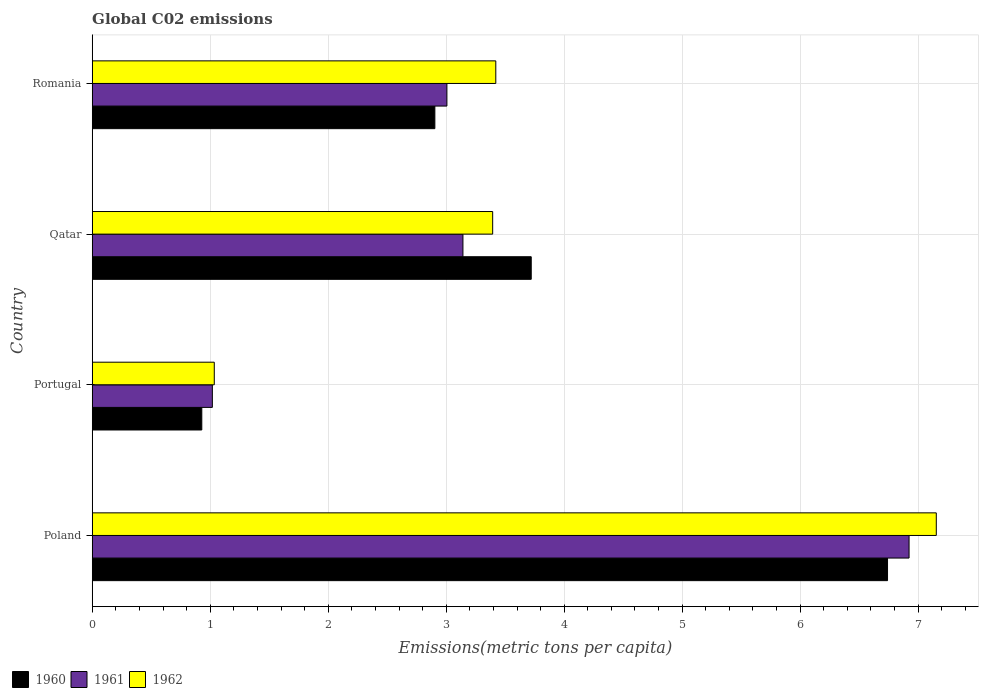How many different coloured bars are there?
Keep it short and to the point. 3. Are the number of bars on each tick of the Y-axis equal?
Offer a terse response. Yes. What is the label of the 1st group of bars from the top?
Provide a succinct answer. Romania. What is the amount of CO2 emitted in in 1961 in Poland?
Your answer should be very brief. 6.92. Across all countries, what is the maximum amount of CO2 emitted in in 1962?
Your answer should be compact. 7.15. Across all countries, what is the minimum amount of CO2 emitted in in 1960?
Your response must be concise. 0.93. In which country was the amount of CO2 emitted in in 1961 minimum?
Your answer should be compact. Portugal. What is the total amount of CO2 emitted in in 1960 in the graph?
Make the answer very short. 14.29. What is the difference between the amount of CO2 emitted in in 1960 in Poland and that in Qatar?
Your answer should be compact. 3.02. What is the difference between the amount of CO2 emitted in in 1961 in Qatar and the amount of CO2 emitted in in 1962 in Portugal?
Your response must be concise. 2.11. What is the average amount of CO2 emitted in in 1962 per country?
Make the answer very short. 3.75. What is the difference between the amount of CO2 emitted in in 1960 and amount of CO2 emitted in in 1961 in Romania?
Keep it short and to the point. -0.1. What is the ratio of the amount of CO2 emitted in in 1962 in Portugal to that in Romania?
Make the answer very short. 0.3. Is the amount of CO2 emitted in in 1962 in Poland less than that in Romania?
Your response must be concise. No. Is the difference between the amount of CO2 emitted in in 1960 in Portugal and Qatar greater than the difference between the amount of CO2 emitted in in 1961 in Portugal and Qatar?
Keep it short and to the point. No. What is the difference between the highest and the second highest amount of CO2 emitted in in 1962?
Give a very brief answer. 3.73. What is the difference between the highest and the lowest amount of CO2 emitted in in 1962?
Your response must be concise. 6.12. In how many countries, is the amount of CO2 emitted in in 1960 greater than the average amount of CO2 emitted in in 1960 taken over all countries?
Offer a very short reply. 2. What does the 1st bar from the top in Romania represents?
Your response must be concise. 1962. What does the 3rd bar from the bottom in Poland represents?
Your answer should be compact. 1962. Is it the case that in every country, the sum of the amount of CO2 emitted in in 1962 and amount of CO2 emitted in in 1960 is greater than the amount of CO2 emitted in in 1961?
Your answer should be compact. Yes. How many bars are there?
Your response must be concise. 12. What is the difference between two consecutive major ticks on the X-axis?
Your answer should be very brief. 1. Are the values on the major ticks of X-axis written in scientific E-notation?
Your answer should be compact. No. Does the graph contain any zero values?
Your response must be concise. No. Does the graph contain grids?
Give a very brief answer. Yes. Where does the legend appear in the graph?
Give a very brief answer. Bottom left. How many legend labels are there?
Make the answer very short. 3. How are the legend labels stacked?
Make the answer very short. Horizontal. What is the title of the graph?
Your answer should be very brief. Global C02 emissions. What is the label or title of the X-axis?
Keep it short and to the point. Emissions(metric tons per capita). What is the Emissions(metric tons per capita) of 1960 in Poland?
Your response must be concise. 6.74. What is the Emissions(metric tons per capita) of 1961 in Poland?
Offer a very short reply. 6.92. What is the Emissions(metric tons per capita) in 1962 in Poland?
Your response must be concise. 7.15. What is the Emissions(metric tons per capita) of 1960 in Portugal?
Make the answer very short. 0.93. What is the Emissions(metric tons per capita) in 1961 in Portugal?
Your answer should be very brief. 1.02. What is the Emissions(metric tons per capita) of 1962 in Portugal?
Offer a very short reply. 1.03. What is the Emissions(metric tons per capita) of 1960 in Qatar?
Give a very brief answer. 3.72. What is the Emissions(metric tons per capita) of 1961 in Qatar?
Provide a succinct answer. 3.14. What is the Emissions(metric tons per capita) of 1962 in Qatar?
Ensure brevity in your answer.  3.39. What is the Emissions(metric tons per capita) in 1960 in Romania?
Provide a short and direct response. 2.9. What is the Emissions(metric tons per capita) of 1961 in Romania?
Your response must be concise. 3.01. What is the Emissions(metric tons per capita) of 1962 in Romania?
Offer a terse response. 3.42. Across all countries, what is the maximum Emissions(metric tons per capita) of 1960?
Provide a succinct answer. 6.74. Across all countries, what is the maximum Emissions(metric tons per capita) in 1961?
Keep it short and to the point. 6.92. Across all countries, what is the maximum Emissions(metric tons per capita) of 1962?
Ensure brevity in your answer.  7.15. Across all countries, what is the minimum Emissions(metric tons per capita) of 1960?
Keep it short and to the point. 0.93. Across all countries, what is the minimum Emissions(metric tons per capita) of 1961?
Provide a short and direct response. 1.02. Across all countries, what is the minimum Emissions(metric tons per capita) in 1962?
Ensure brevity in your answer.  1.03. What is the total Emissions(metric tons per capita) in 1960 in the graph?
Ensure brevity in your answer.  14.29. What is the total Emissions(metric tons per capita) of 1961 in the graph?
Give a very brief answer. 14.09. What is the total Emissions(metric tons per capita) in 1962 in the graph?
Offer a very short reply. 15. What is the difference between the Emissions(metric tons per capita) of 1960 in Poland and that in Portugal?
Provide a short and direct response. 5.81. What is the difference between the Emissions(metric tons per capita) of 1961 in Poland and that in Portugal?
Offer a terse response. 5.9. What is the difference between the Emissions(metric tons per capita) of 1962 in Poland and that in Portugal?
Your answer should be compact. 6.12. What is the difference between the Emissions(metric tons per capita) in 1960 in Poland and that in Qatar?
Ensure brevity in your answer.  3.02. What is the difference between the Emissions(metric tons per capita) of 1961 in Poland and that in Qatar?
Keep it short and to the point. 3.78. What is the difference between the Emissions(metric tons per capita) in 1962 in Poland and that in Qatar?
Offer a very short reply. 3.76. What is the difference between the Emissions(metric tons per capita) of 1960 in Poland and that in Romania?
Your answer should be very brief. 3.84. What is the difference between the Emissions(metric tons per capita) of 1961 in Poland and that in Romania?
Your answer should be compact. 3.92. What is the difference between the Emissions(metric tons per capita) of 1962 in Poland and that in Romania?
Offer a terse response. 3.73. What is the difference between the Emissions(metric tons per capita) of 1960 in Portugal and that in Qatar?
Ensure brevity in your answer.  -2.79. What is the difference between the Emissions(metric tons per capita) in 1961 in Portugal and that in Qatar?
Make the answer very short. -2.12. What is the difference between the Emissions(metric tons per capita) in 1962 in Portugal and that in Qatar?
Keep it short and to the point. -2.36. What is the difference between the Emissions(metric tons per capita) in 1960 in Portugal and that in Romania?
Offer a terse response. -1.98. What is the difference between the Emissions(metric tons per capita) in 1961 in Portugal and that in Romania?
Your answer should be compact. -1.99. What is the difference between the Emissions(metric tons per capita) in 1962 in Portugal and that in Romania?
Provide a short and direct response. -2.39. What is the difference between the Emissions(metric tons per capita) in 1960 in Qatar and that in Romania?
Your answer should be very brief. 0.82. What is the difference between the Emissions(metric tons per capita) of 1961 in Qatar and that in Romania?
Keep it short and to the point. 0.14. What is the difference between the Emissions(metric tons per capita) in 1962 in Qatar and that in Romania?
Your answer should be compact. -0.03. What is the difference between the Emissions(metric tons per capita) of 1960 in Poland and the Emissions(metric tons per capita) of 1961 in Portugal?
Ensure brevity in your answer.  5.72. What is the difference between the Emissions(metric tons per capita) of 1960 in Poland and the Emissions(metric tons per capita) of 1962 in Portugal?
Ensure brevity in your answer.  5.71. What is the difference between the Emissions(metric tons per capita) of 1961 in Poland and the Emissions(metric tons per capita) of 1962 in Portugal?
Make the answer very short. 5.89. What is the difference between the Emissions(metric tons per capita) in 1960 in Poland and the Emissions(metric tons per capita) in 1961 in Qatar?
Your response must be concise. 3.6. What is the difference between the Emissions(metric tons per capita) in 1960 in Poland and the Emissions(metric tons per capita) in 1962 in Qatar?
Offer a terse response. 3.35. What is the difference between the Emissions(metric tons per capita) of 1961 in Poland and the Emissions(metric tons per capita) of 1962 in Qatar?
Your response must be concise. 3.53. What is the difference between the Emissions(metric tons per capita) of 1960 in Poland and the Emissions(metric tons per capita) of 1961 in Romania?
Provide a short and direct response. 3.73. What is the difference between the Emissions(metric tons per capita) of 1960 in Poland and the Emissions(metric tons per capita) of 1962 in Romania?
Give a very brief answer. 3.32. What is the difference between the Emissions(metric tons per capita) of 1961 in Poland and the Emissions(metric tons per capita) of 1962 in Romania?
Give a very brief answer. 3.5. What is the difference between the Emissions(metric tons per capita) in 1960 in Portugal and the Emissions(metric tons per capita) in 1961 in Qatar?
Keep it short and to the point. -2.21. What is the difference between the Emissions(metric tons per capita) in 1960 in Portugal and the Emissions(metric tons per capita) in 1962 in Qatar?
Make the answer very short. -2.47. What is the difference between the Emissions(metric tons per capita) in 1961 in Portugal and the Emissions(metric tons per capita) in 1962 in Qatar?
Keep it short and to the point. -2.38. What is the difference between the Emissions(metric tons per capita) in 1960 in Portugal and the Emissions(metric tons per capita) in 1961 in Romania?
Your answer should be compact. -2.08. What is the difference between the Emissions(metric tons per capita) in 1960 in Portugal and the Emissions(metric tons per capita) in 1962 in Romania?
Provide a succinct answer. -2.49. What is the difference between the Emissions(metric tons per capita) of 1961 in Portugal and the Emissions(metric tons per capita) of 1962 in Romania?
Ensure brevity in your answer.  -2.4. What is the difference between the Emissions(metric tons per capita) of 1960 in Qatar and the Emissions(metric tons per capita) of 1961 in Romania?
Offer a very short reply. 0.71. What is the difference between the Emissions(metric tons per capita) in 1960 in Qatar and the Emissions(metric tons per capita) in 1962 in Romania?
Provide a succinct answer. 0.3. What is the difference between the Emissions(metric tons per capita) in 1961 in Qatar and the Emissions(metric tons per capita) in 1962 in Romania?
Offer a very short reply. -0.28. What is the average Emissions(metric tons per capita) of 1960 per country?
Offer a terse response. 3.57. What is the average Emissions(metric tons per capita) of 1961 per country?
Your answer should be very brief. 3.52. What is the average Emissions(metric tons per capita) in 1962 per country?
Ensure brevity in your answer.  3.75. What is the difference between the Emissions(metric tons per capita) of 1960 and Emissions(metric tons per capita) of 1961 in Poland?
Your answer should be very brief. -0.18. What is the difference between the Emissions(metric tons per capita) of 1960 and Emissions(metric tons per capita) of 1962 in Poland?
Provide a short and direct response. -0.41. What is the difference between the Emissions(metric tons per capita) in 1961 and Emissions(metric tons per capita) in 1962 in Poland?
Offer a terse response. -0.23. What is the difference between the Emissions(metric tons per capita) in 1960 and Emissions(metric tons per capita) in 1961 in Portugal?
Your response must be concise. -0.09. What is the difference between the Emissions(metric tons per capita) of 1960 and Emissions(metric tons per capita) of 1962 in Portugal?
Your response must be concise. -0.11. What is the difference between the Emissions(metric tons per capita) of 1961 and Emissions(metric tons per capita) of 1962 in Portugal?
Ensure brevity in your answer.  -0.02. What is the difference between the Emissions(metric tons per capita) in 1960 and Emissions(metric tons per capita) in 1961 in Qatar?
Offer a terse response. 0.58. What is the difference between the Emissions(metric tons per capita) of 1960 and Emissions(metric tons per capita) of 1962 in Qatar?
Make the answer very short. 0.33. What is the difference between the Emissions(metric tons per capita) in 1961 and Emissions(metric tons per capita) in 1962 in Qatar?
Provide a short and direct response. -0.25. What is the difference between the Emissions(metric tons per capita) in 1960 and Emissions(metric tons per capita) in 1961 in Romania?
Your response must be concise. -0.1. What is the difference between the Emissions(metric tons per capita) in 1960 and Emissions(metric tons per capita) in 1962 in Romania?
Offer a terse response. -0.52. What is the difference between the Emissions(metric tons per capita) of 1961 and Emissions(metric tons per capita) of 1962 in Romania?
Make the answer very short. -0.41. What is the ratio of the Emissions(metric tons per capita) of 1960 in Poland to that in Portugal?
Offer a very short reply. 7.26. What is the ratio of the Emissions(metric tons per capita) of 1961 in Poland to that in Portugal?
Your answer should be compact. 6.8. What is the ratio of the Emissions(metric tons per capita) in 1962 in Poland to that in Portugal?
Your answer should be compact. 6.92. What is the ratio of the Emissions(metric tons per capita) of 1960 in Poland to that in Qatar?
Your response must be concise. 1.81. What is the ratio of the Emissions(metric tons per capita) of 1961 in Poland to that in Qatar?
Your response must be concise. 2.2. What is the ratio of the Emissions(metric tons per capita) in 1962 in Poland to that in Qatar?
Make the answer very short. 2.11. What is the ratio of the Emissions(metric tons per capita) in 1960 in Poland to that in Romania?
Provide a succinct answer. 2.32. What is the ratio of the Emissions(metric tons per capita) of 1961 in Poland to that in Romania?
Provide a succinct answer. 2.3. What is the ratio of the Emissions(metric tons per capita) in 1962 in Poland to that in Romania?
Provide a short and direct response. 2.09. What is the ratio of the Emissions(metric tons per capita) of 1960 in Portugal to that in Qatar?
Offer a very short reply. 0.25. What is the ratio of the Emissions(metric tons per capita) of 1961 in Portugal to that in Qatar?
Keep it short and to the point. 0.32. What is the ratio of the Emissions(metric tons per capita) of 1962 in Portugal to that in Qatar?
Provide a short and direct response. 0.3. What is the ratio of the Emissions(metric tons per capita) of 1960 in Portugal to that in Romania?
Offer a terse response. 0.32. What is the ratio of the Emissions(metric tons per capita) in 1961 in Portugal to that in Romania?
Offer a very short reply. 0.34. What is the ratio of the Emissions(metric tons per capita) in 1962 in Portugal to that in Romania?
Offer a terse response. 0.3. What is the ratio of the Emissions(metric tons per capita) of 1960 in Qatar to that in Romania?
Offer a terse response. 1.28. What is the ratio of the Emissions(metric tons per capita) of 1961 in Qatar to that in Romania?
Offer a terse response. 1.05. What is the ratio of the Emissions(metric tons per capita) in 1962 in Qatar to that in Romania?
Offer a very short reply. 0.99. What is the difference between the highest and the second highest Emissions(metric tons per capita) in 1960?
Your answer should be compact. 3.02. What is the difference between the highest and the second highest Emissions(metric tons per capita) in 1961?
Offer a very short reply. 3.78. What is the difference between the highest and the second highest Emissions(metric tons per capita) of 1962?
Provide a short and direct response. 3.73. What is the difference between the highest and the lowest Emissions(metric tons per capita) of 1960?
Offer a very short reply. 5.81. What is the difference between the highest and the lowest Emissions(metric tons per capita) of 1961?
Offer a terse response. 5.9. What is the difference between the highest and the lowest Emissions(metric tons per capita) in 1962?
Provide a short and direct response. 6.12. 